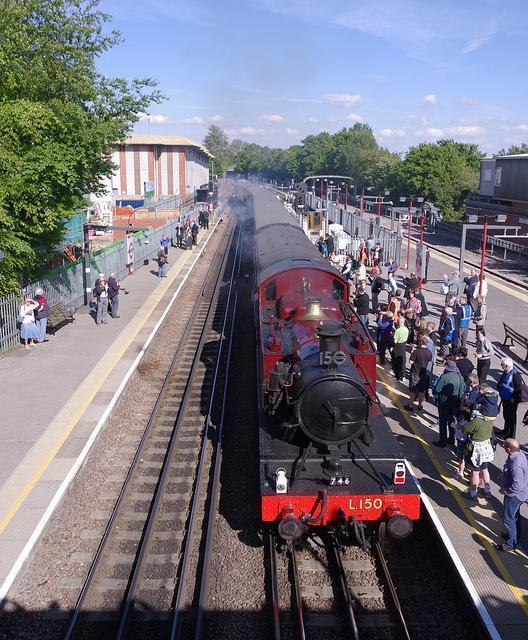What is the gold object near the front of the train?
Choose the right answer from the provided options to respond to the question.
Options: Shield, handle, bell, helmet. Bell. 